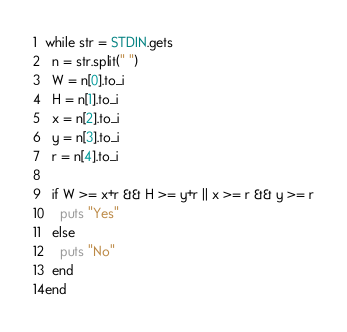Convert code to text. <code><loc_0><loc_0><loc_500><loc_500><_Ruby_>while str = STDIN.gets
  n = str.split(" ")
  W = n[0].to_i
  H = n[1].to_i
  x = n[2].to_i
  y = n[3].to_i
  r = n[4].to_i

  if W >= x+r && H >= y+r || x >= r && y >= r
    puts "Yes"
  else
    puts "No"
  end
end

</code> 